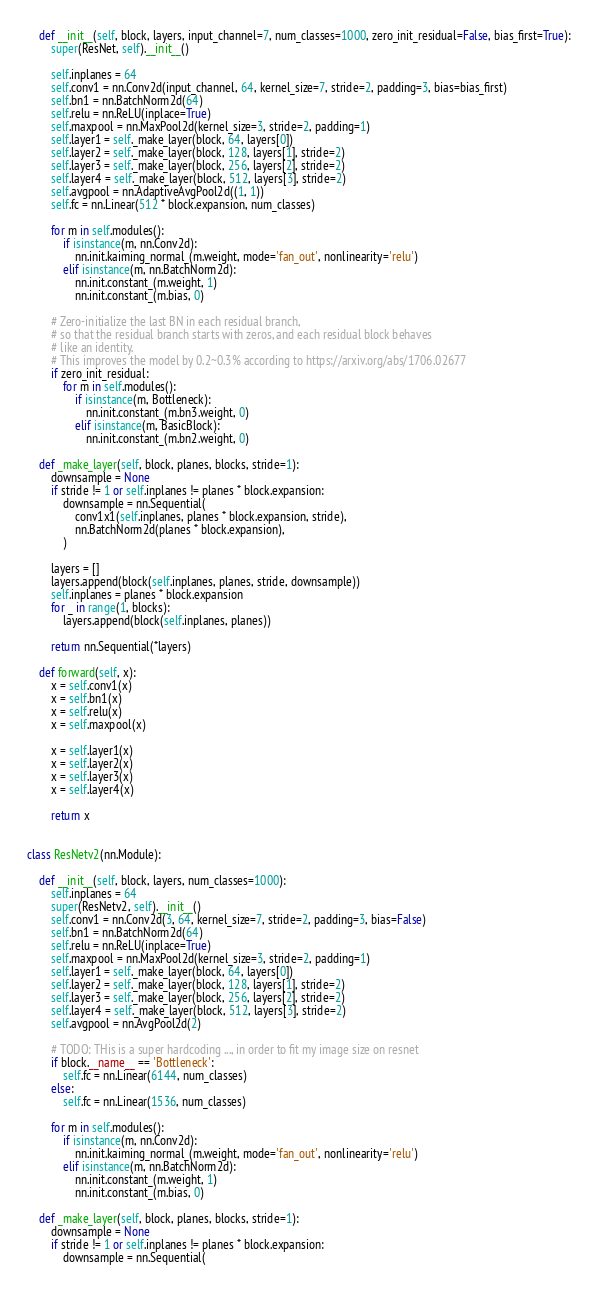<code> <loc_0><loc_0><loc_500><loc_500><_Python_>    def __init__(self, block, layers, input_channel=7, num_classes=1000, zero_init_residual=False, bias_first=True):
        super(ResNet, self).__init__()

        self.inplanes = 64
        self.conv1 = nn.Conv2d(input_channel, 64, kernel_size=7, stride=2, padding=3, bias=bias_first)
        self.bn1 = nn.BatchNorm2d(64)
        self.relu = nn.ReLU(inplace=True)
        self.maxpool = nn.MaxPool2d(kernel_size=3, stride=2, padding=1)
        self.layer1 = self._make_layer(block, 64, layers[0])
        self.layer2 = self._make_layer(block, 128, layers[1], stride=2)
        self.layer3 = self._make_layer(block, 256, layers[2], stride=2)
        self.layer4 = self._make_layer(block, 512, layers[3], stride=2)
        self.avgpool = nn.AdaptiveAvgPool2d((1, 1))
        self.fc = nn.Linear(512 * block.expansion, num_classes)

        for m in self.modules():
            if isinstance(m, nn.Conv2d):
                nn.init.kaiming_normal_(m.weight, mode='fan_out', nonlinearity='relu')
            elif isinstance(m, nn.BatchNorm2d):
                nn.init.constant_(m.weight, 1)
                nn.init.constant_(m.bias, 0)

        # Zero-initialize the last BN in each residual branch,
        # so that the residual branch starts with zeros, and each residual block behaves
        # like an identity.
        # This improves the model by 0.2~0.3% according to https://arxiv.org/abs/1706.02677
        if zero_init_residual:
            for m in self.modules():
                if isinstance(m, Bottleneck):
                    nn.init.constant_(m.bn3.weight, 0)
                elif isinstance(m, BasicBlock):
                    nn.init.constant_(m.bn2.weight, 0)

    def _make_layer(self, block, planes, blocks, stride=1):
        downsample = None
        if stride != 1 or self.inplanes != planes * block.expansion:
            downsample = nn.Sequential(
                conv1x1(self.inplanes, planes * block.expansion, stride),
                nn.BatchNorm2d(planes * block.expansion),
            )

        layers = []
        layers.append(block(self.inplanes, planes, stride, downsample))
        self.inplanes = planes * block.expansion
        for _ in range(1, blocks):
            layers.append(block(self.inplanes, planes))

        return nn.Sequential(*layers)

    def forward(self, x):
        x = self.conv1(x)
        x = self.bn1(x)
        x = self.relu(x)
        x = self.maxpool(x)

        x = self.layer1(x)
        x = self.layer2(x)
        x = self.layer3(x)
        x = self.layer4(x)

        return x


class ResNetv2(nn.Module):

    def __init__(self, block, layers, num_classes=1000):
        self.inplanes = 64
        super(ResNetv2, self).__init__()
        self.conv1 = nn.Conv2d(3, 64, kernel_size=7, stride=2, padding=3, bias=False)
        self.bn1 = nn.BatchNorm2d(64)
        self.relu = nn.ReLU(inplace=True)
        self.maxpool = nn.MaxPool2d(kernel_size=3, stride=2, padding=1)
        self.layer1 = self._make_layer(block, 64, layers[0])
        self.layer2 = self._make_layer(block, 128, layers[1], stride=2)
        self.layer3 = self._make_layer(block, 256, layers[2], stride=2)
        self.layer4 = self._make_layer(block, 512, layers[3], stride=2)
        self.avgpool = nn.AvgPool2d(2)

        # TODO: THis is a super hardcoding ..., in order to fit my image size on resnet
        if block.__name__ == 'Bottleneck':
            self.fc = nn.Linear(6144, num_classes)
        else:
            self.fc = nn.Linear(1536, num_classes)

        for m in self.modules():
            if isinstance(m, nn.Conv2d):
                nn.init.kaiming_normal_(m.weight, mode='fan_out', nonlinearity='relu')
            elif isinstance(m, nn.BatchNorm2d):
                nn.init.constant_(m.weight, 1)
                nn.init.constant_(m.bias, 0)

    def _make_layer(self, block, planes, blocks, stride=1):
        downsample = None
        if stride != 1 or self.inplanes != planes * block.expansion:
            downsample = nn.Sequential(</code> 